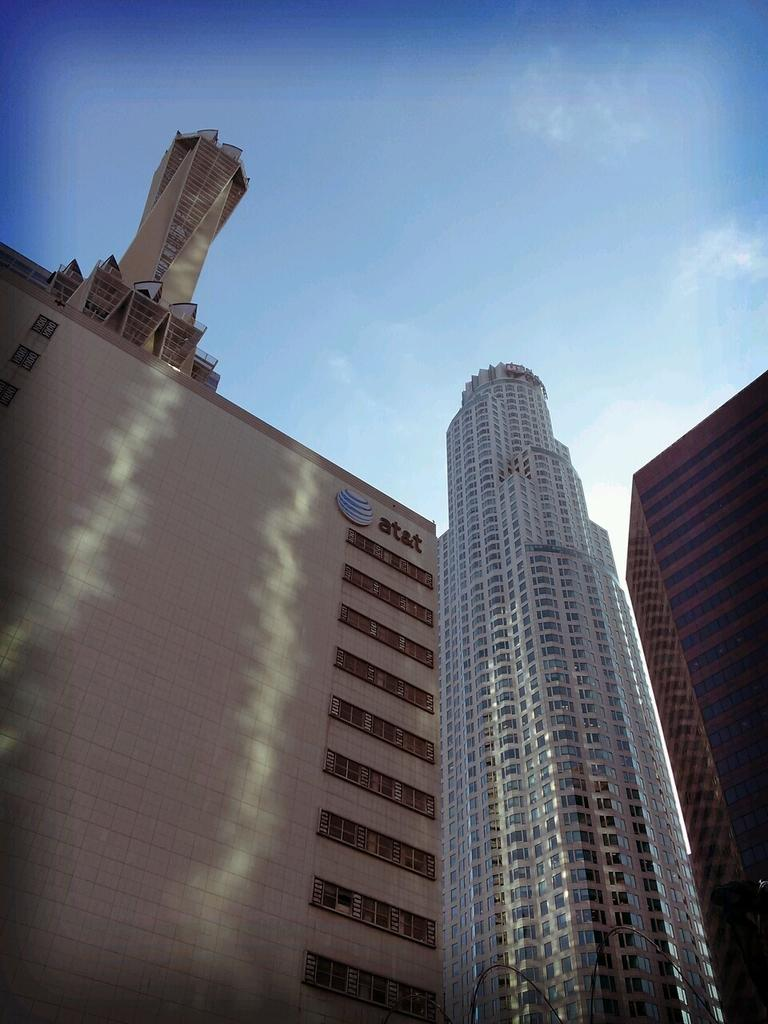What type of structures can be seen in the image? There are buildings in the image. What can be seen in the background of the image? The sky is visible in the background of the image. What date is marked on the calendar in the image? There is no calendar present in the image. What type of mountain can be seen in the image? There is no mountain present in the image. 